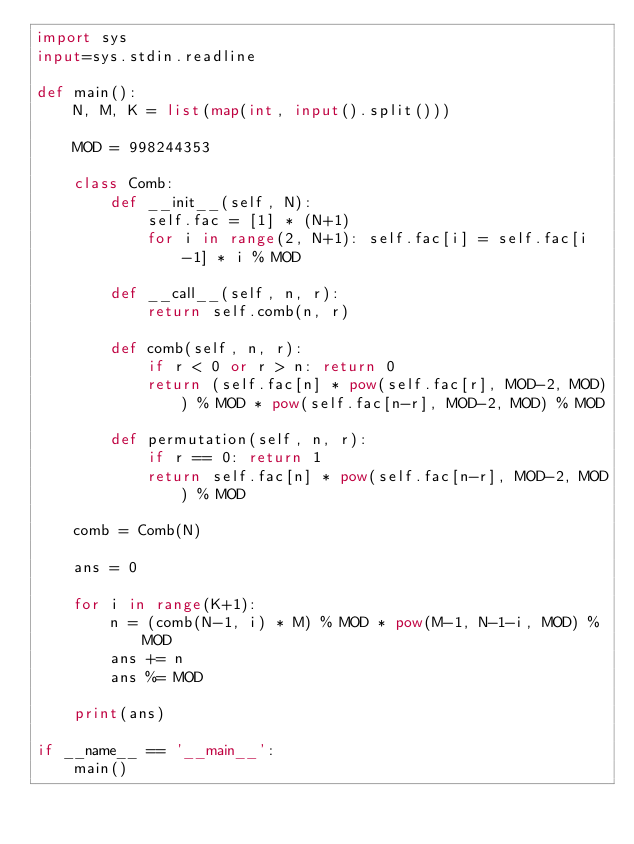Convert code to text. <code><loc_0><loc_0><loc_500><loc_500><_Python_>import sys
input=sys.stdin.readline

def main():
    N, M, K = list(map(int, input().split()))

    MOD = 998244353

    class Comb:
        def __init__(self, N):
            self.fac = [1] * (N+1)
            for i in range(2, N+1): self.fac[i] = self.fac[i-1] * i % MOD

        def __call__(self, n, r):
            return self.comb(n, r)

        def comb(self, n, r):
            if r < 0 or r > n: return 0
            return (self.fac[n] * pow(self.fac[r], MOD-2, MOD)) % MOD * pow(self.fac[n-r], MOD-2, MOD) % MOD

        def permutation(self, n, r):
            if r == 0: return 1
            return self.fac[n] * pow(self.fac[n-r], MOD-2, MOD) % MOD

    comb = Comb(N)

    ans = 0

    for i in range(K+1):
        n = (comb(N-1, i) * M) % MOD * pow(M-1, N-1-i, MOD) % MOD
        ans += n
        ans %= MOD

    print(ans)

if __name__ == '__main__':
    main()
</code> 